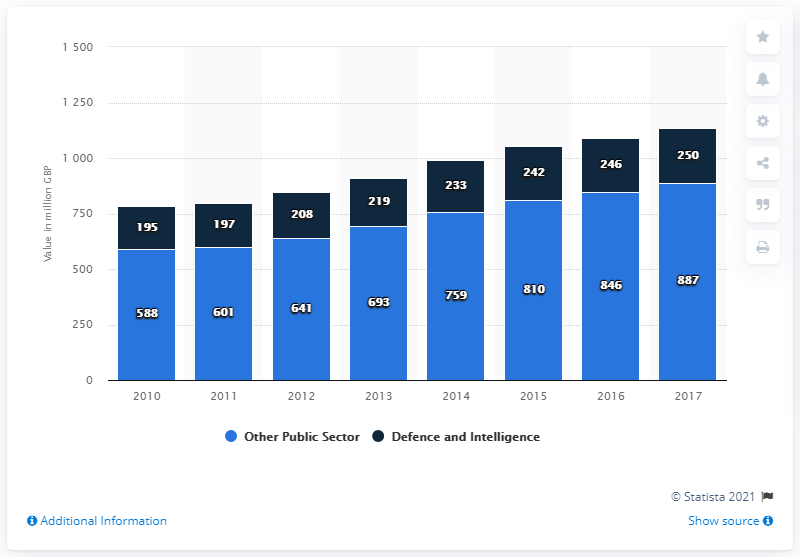Specify some key components in this picture. In 2017, the estimated size of the cyber security market in the defense and intelligence sector was approximately 250 million. 